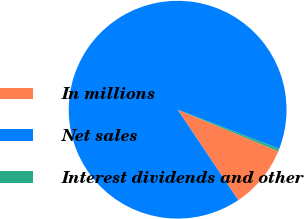Convert chart to OTSL. <chart><loc_0><loc_0><loc_500><loc_500><pie_chart><fcel>In millions<fcel>Net sales<fcel>Interest dividends and other<nl><fcel>9.38%<fcel>90.23%<fcel>0.39%<nl></chart> 